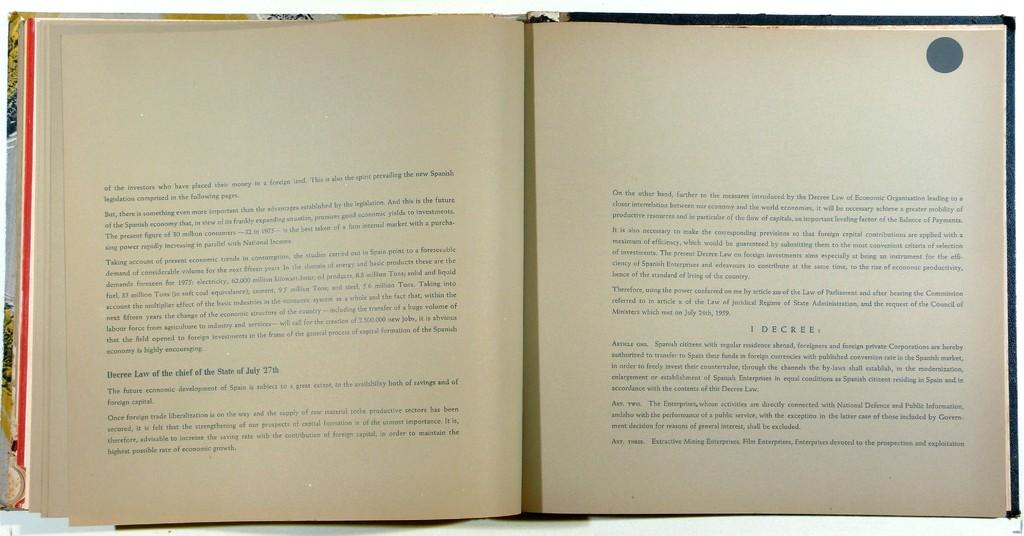<image>
Create a compact narrative representing the image presented. the word decree is on an open book 